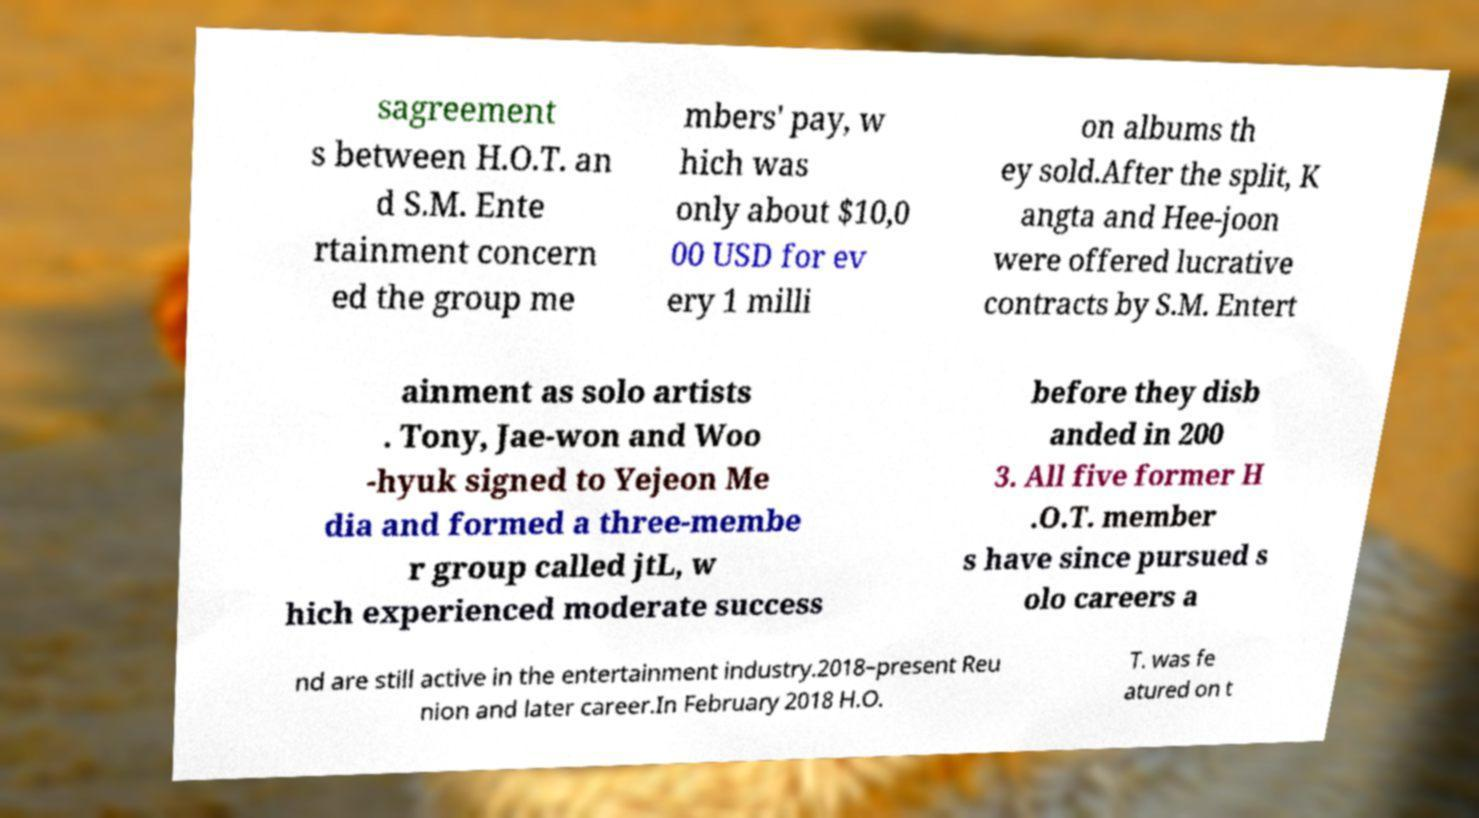I need the written content from this picture converted into text. Can you do that? sagreement s between H.O.T. an d S.M. Ente rtainment concern ed the group me mbers' pay, w hich was only about $10,0 00 USD for ev ery 1 milli on albums th ey sold.After the split, K angta and Hee-joon were offered lucrative contracts by S.M. Entert ainment as solo artists . Tony, Jae-won and Woo -hyuk signed to Yejeon Me dia and formed a three-membe r group called jtL, w hich experienced moderate success before they disb anded in 200 3. All five former H .O.T. member s have since pursued s olo careers a nd are still active in the entertainment industry.2018–present Reu nion and later career.In February 2018 H.O. T. was fe atured on t 